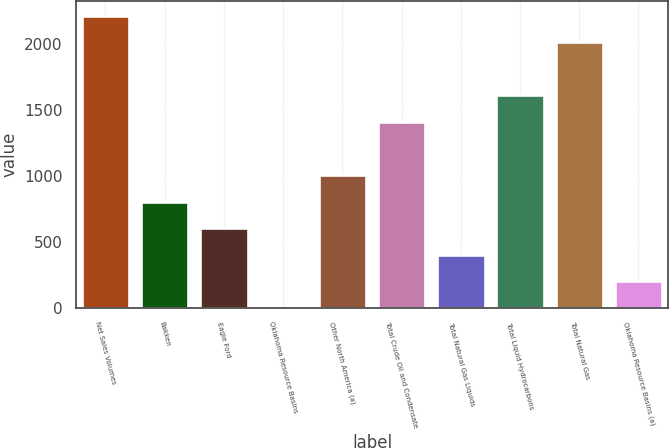Convert chart to OTSL. <chart><loc_0><loc_0><loc_500><loc_500><bar_chart><fcel>Net Sales Volumes<fcel>Bakken<fcel>Eagle Ford<fcel>Oklahoma Resource Basins<fcel>Other North America (a)<fcel>Total Crude Oil and Condensate<fcel>Total Natural Gas Liquids<fcel>Total Liquid Hydrocarbons<fcel>Total Natural Gas<fcel>Oklahoma Resource Basins (a)<nl><fcel>2213.1<fcel>805.4<fcel>604.3<fcel>1<fcel>1006.5<fcel>1408.7<fcel>403.2<fcel>1609.8<fcel>2012<fcel>202.1<nl></chart> 